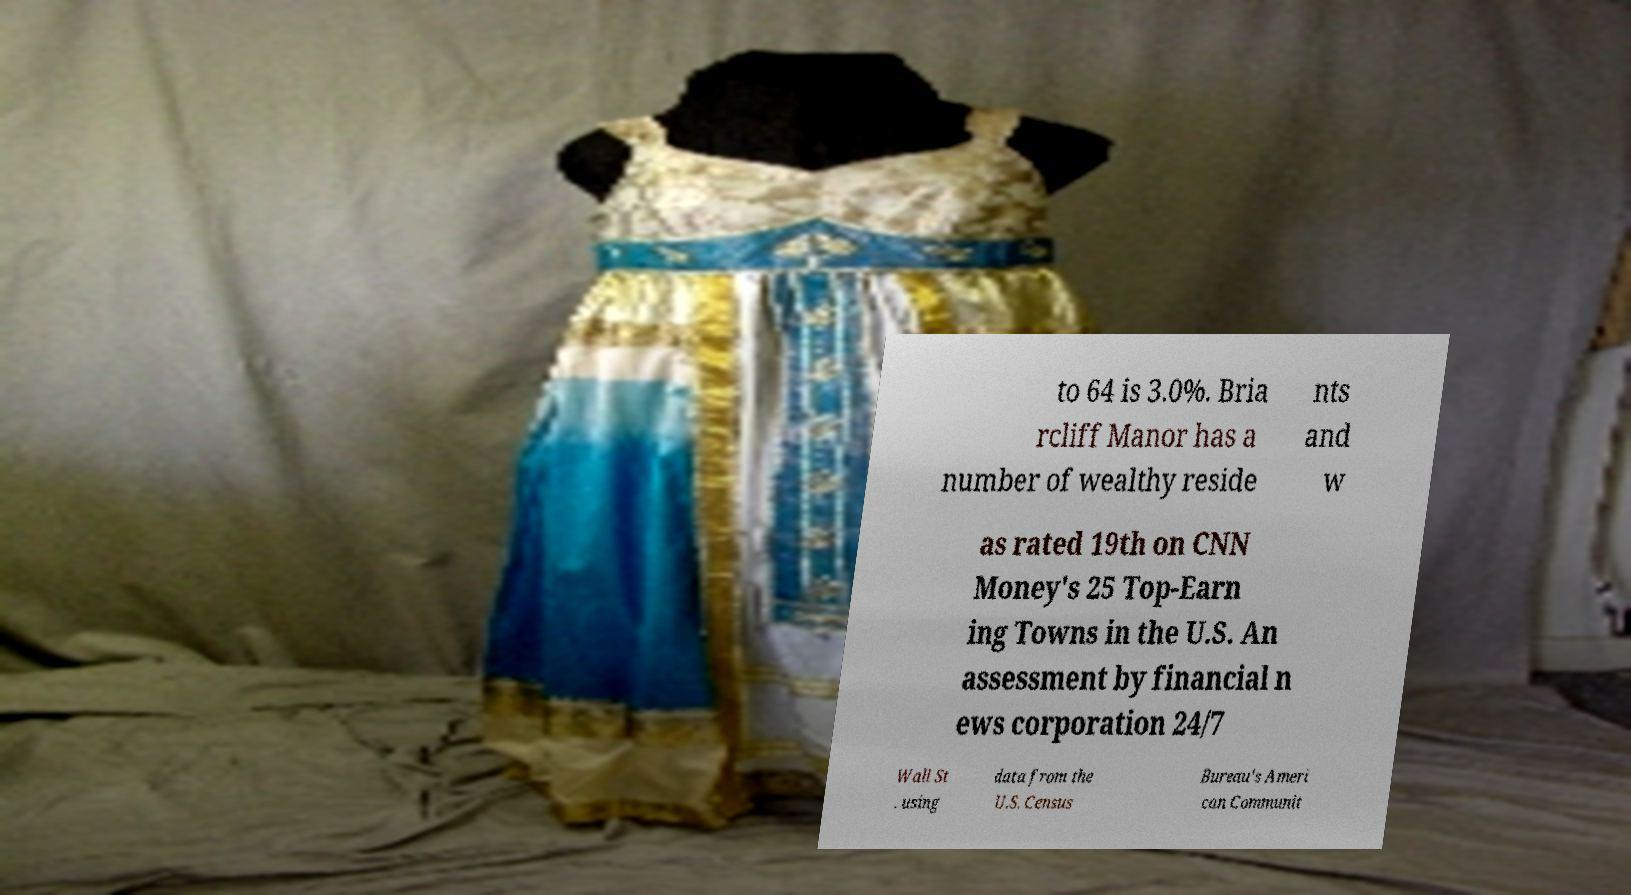What messages or text are displayed in this image? I need them in a readable, typed format. to 64 is 3.0%. Bria rcliff Manor has a number of wealthy reside nts and w as rated 19th on CNN Money's 25 Top-Earn ing Towns in the U.S. An assessment by financial n ews corporation 24/7 Wall St . using data from the U.S. Census Bureau's Ameri can Communit 